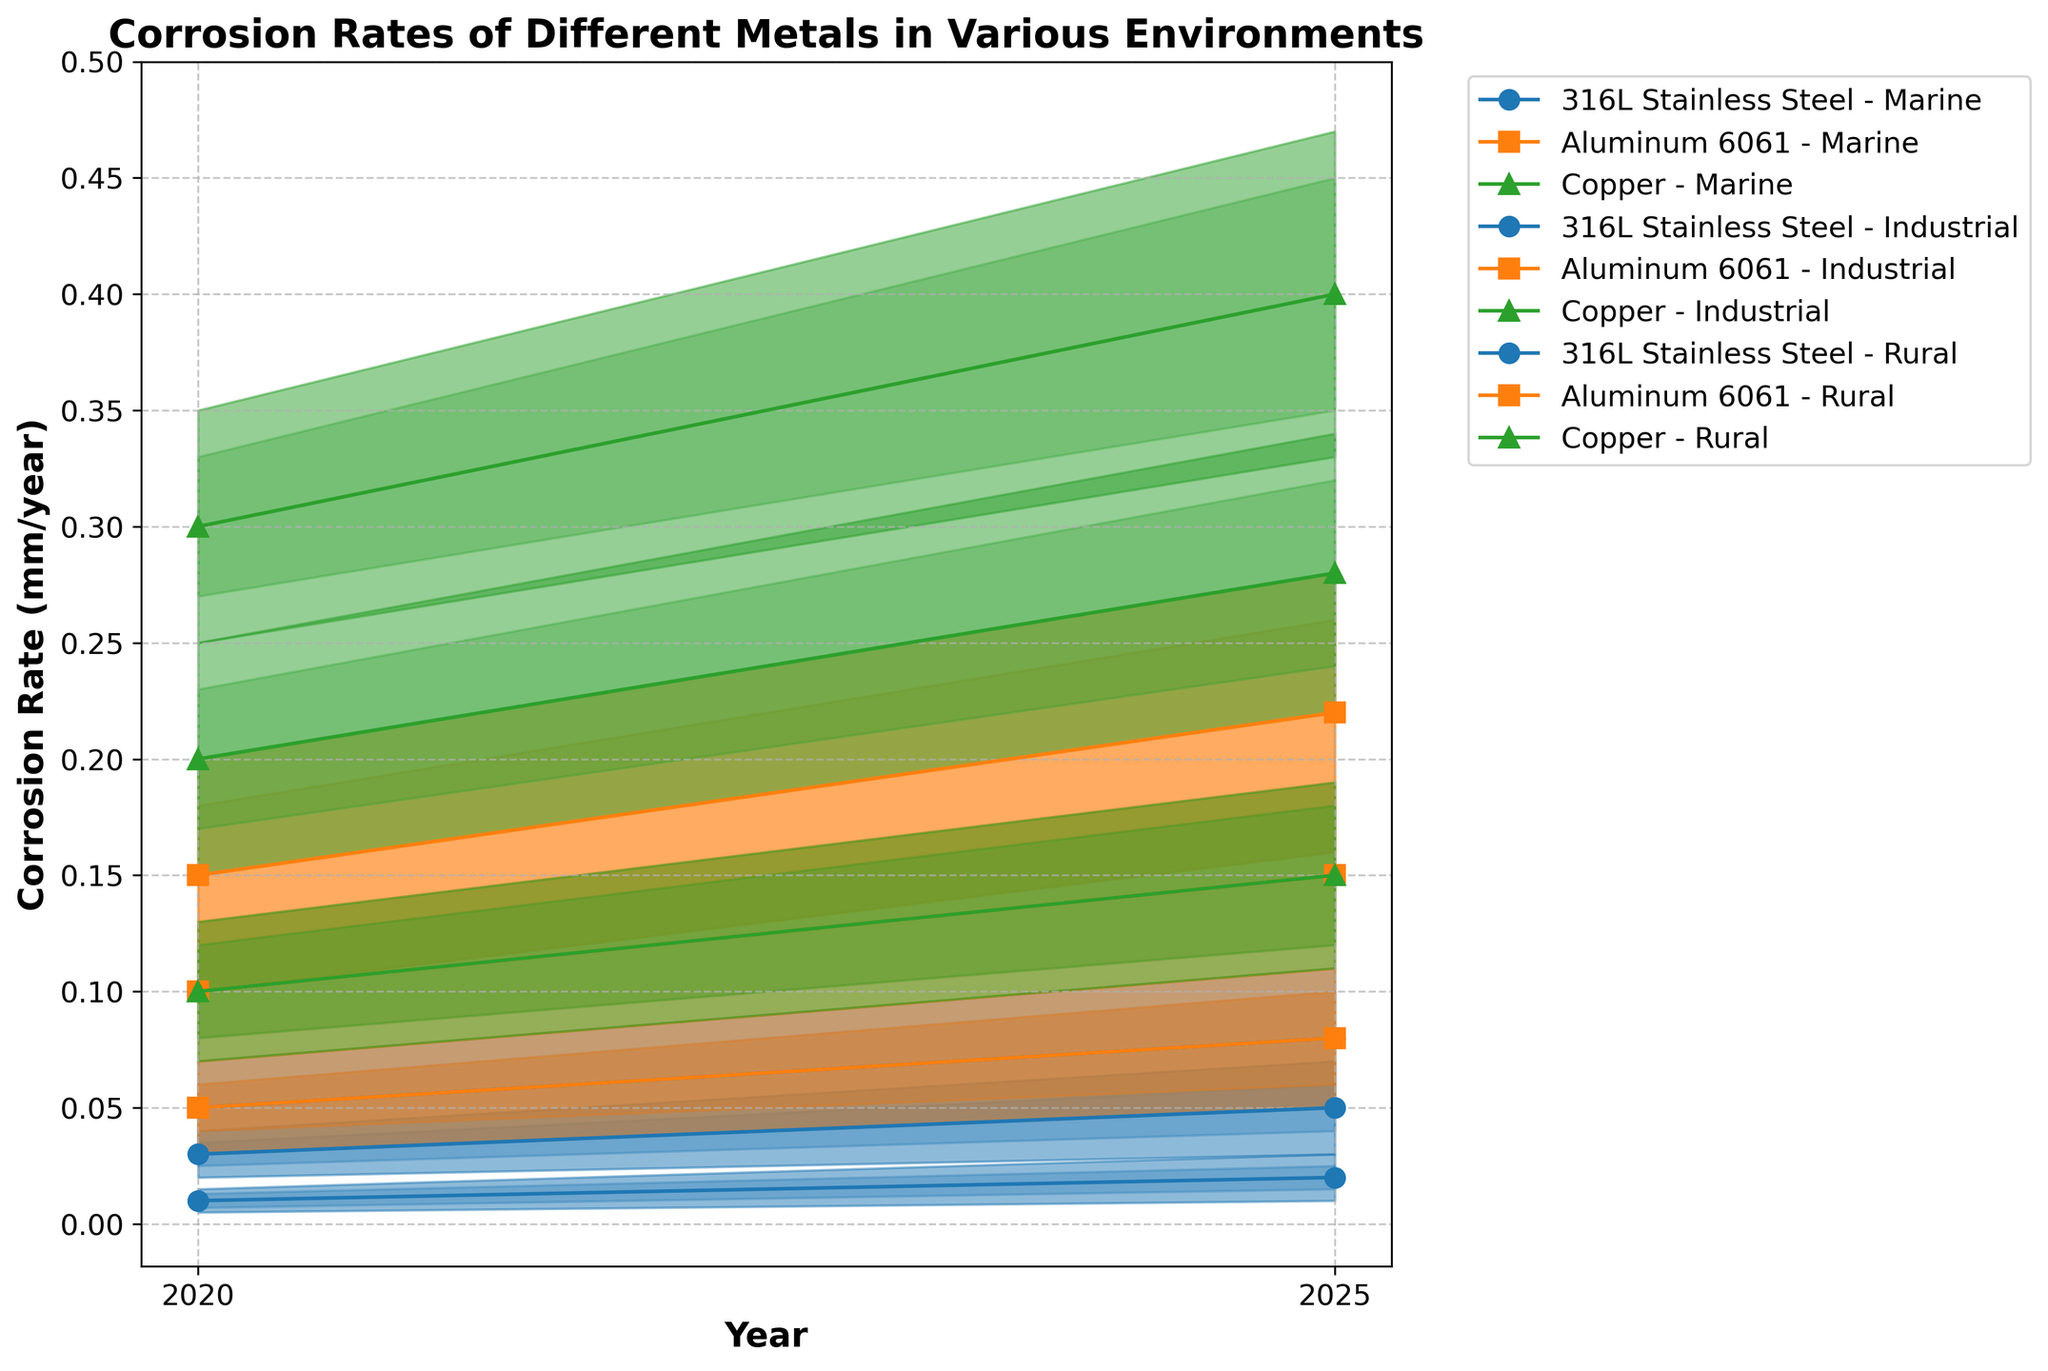What is the median corrosion rate of 316L Stainless Steel in a marine environment in 2025? Observe the median corrosion rate for 316L Stainless Steel in the marine environment for the year 2025 from the plot.
Answer: 0.08 mm/year What are the upper and lower bounds of the corrosion rate for Aluminum 6061 in an industrial environment in 2020? Look at the fan chart for Aluminum 6061 in the industrial environment for 2020; specifically, check the upper and lower bounds.
Answer: 0.13 mm/year (upper), 0.07 mm/year (lower) Which metal has the highest median corrosion rate in a rural environment in 2025? Compare the median corrosion rates in a rural environment in 2025 for each metal; Copper, Aluminum 6061, and 316L Stainless Steel.
Answer: Copper How does the median corrosion rate of Copper in marine environments change from 2020 to 2025? Check the plot's median corrosion rates for Copper in marine environments for both 2020 and 2025, then calculate the difference.
Answer: Increases by 0.10 mm/year In which environment does 316L Stainless Steel have the lowest corrosion rate in 2020? Compare the median corrosion rates of 316L Stainless Steel across marine, industrial, and rural environments for 2020 in the plot.
Answer: Rural What is the range of the middle 60% of corrosion rates for Aluminum 6061 in marine environments in 2025? Calculate the range by subtracting the lower20 value from the upper20 value for Aluminum 6061 in the marine environment in 2025.
Answer: 0.26 - 0.18 = 0.08 mm/year Which metal shows the greatest increase in median corrosion rate in an industrial environment from 2020 to 2025? Note the median corrosion rates for each metal in the industrial environment for both 2020 and 2025, then determine which metal's rate increases the most.
Answer: Copper In 2025, which environmental condition causes the highest upper10 corrosion rate for 316L Stainless Steel? Identify the upper10 corrosion rates for 316L Stainless Steel across all environments in 2025 and compare them.
Answer: Marine Which metal has the smallest uncertainty range (difference between upper10 and lower10) in rural environments in 2020? For each metal in rural conditions in 2020, calculate the uncertainty range and identify the smallest.
Answer: 316L Stainless Steel What is the difference in the upper20 corrosion rate for Copper between marine and rural environments in 2025? Identify the upper20 values for Copper in both marine and rural environments in 2025 from the plot and subtract the rural rate from the marine rate.
Answer: 0.45 - 0.18 = 0.27 mm/year 